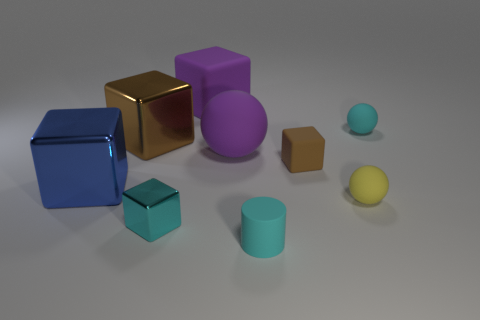Is the tiny metallic thing the same color as the cylinder?
Provide a short and direct response. Yes. There is a big cube that is right of the tiny cyan shiny thing to the left of the large purple ball; what is its color?
Your answer should be compact. Purple. How many rubber objects are both to the right of the small cylinder and behind the brown shiny cube?
Give a very brief answer. 1. How many other red metal objects are the same shape as the small metallic thing?
Provide a short and direct response. 0. Is the material of the blue block the same as the yellow object?
Provide a succinct answer. No. There is a thing on the right side of the matte sphere in front of the tiny brown matte cube; what is its shape?
Your answer should be very brief. Sphere. How many small cyan spheres are in front of the matte ball right of the tiny yellow rubber thing?
Offer a very short reply. 0. What material is the block that is in front of the tiny brown rubber cube and to the right of the large blue thing?
Keep it short and to the point. Metal. There is another metal object that is the same size as the blue metal object; what shape is it?
Make the answer very short. Cube. There is a large object that is behind the small cyan thing behind the big purple matte object in front of the brown metal cube; what color is it?
Give a very brief answer. Purple. 